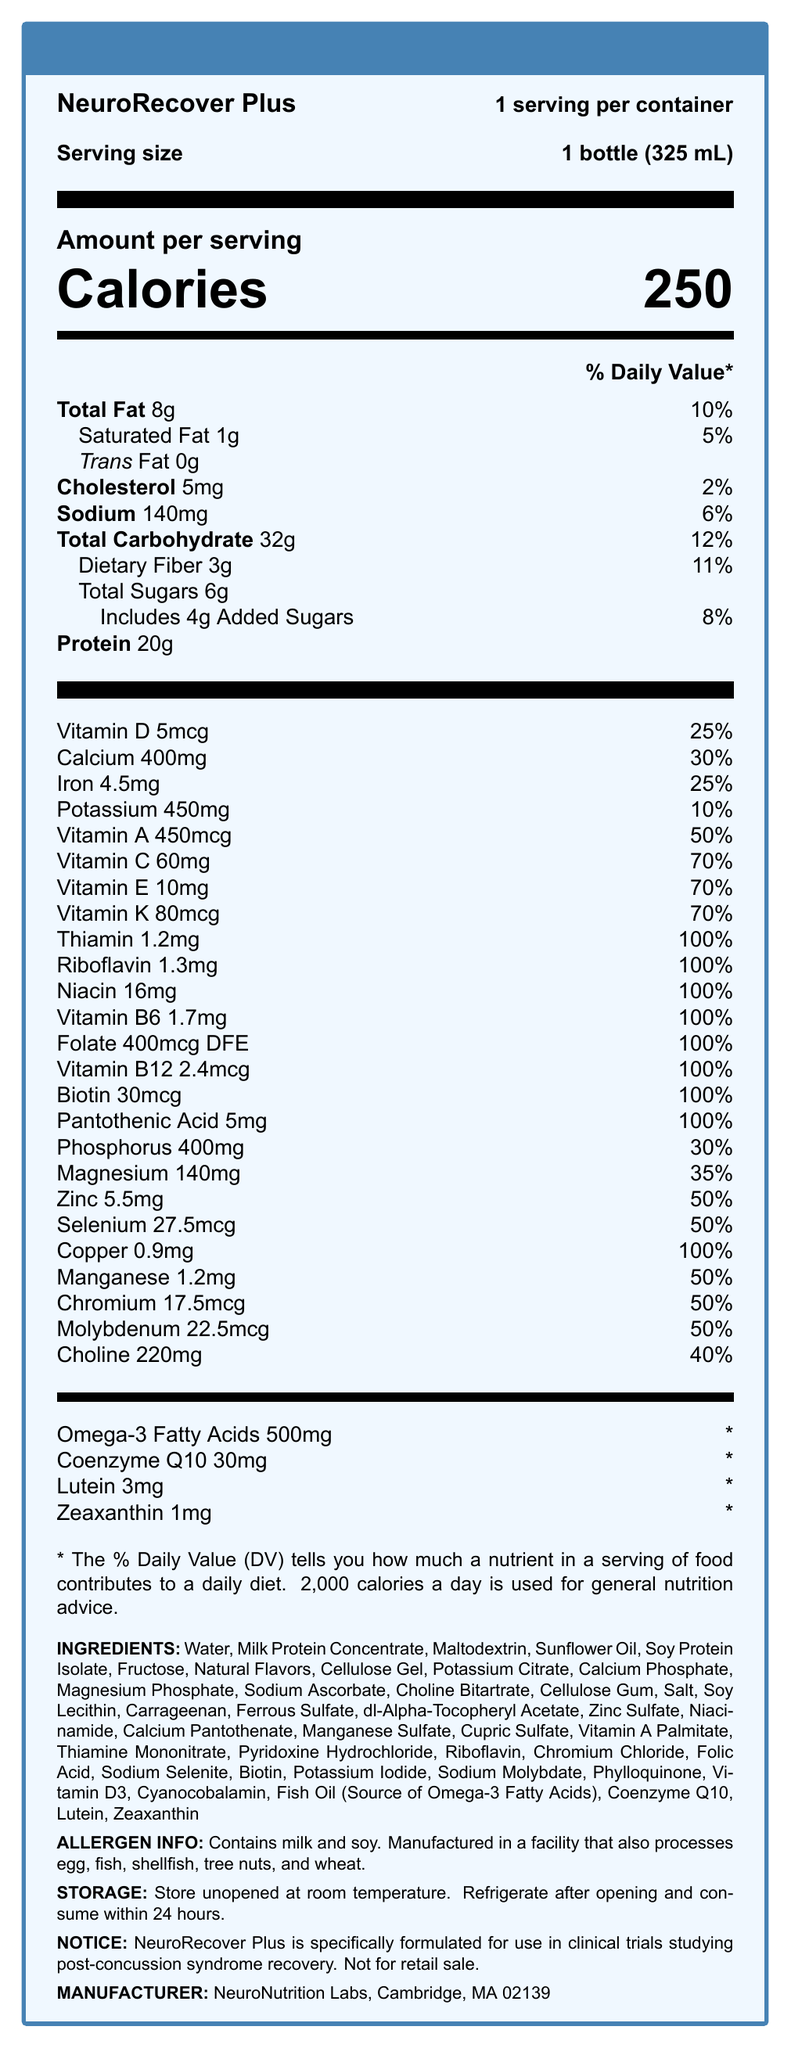what is the serving size of NeuroRecover Plus? The serving size is clearly stated as "1 bottle (325 mL)" in the document.
Answer: 1 bottle (325 mL) how many calories are in one serving? The document lists the calories per serving as 250.
Answer: 250 what is the percentage of daily value for calcium? The document specifies that the daily value for calcium is 30%.
Answer: 30% how much protein does one serving contain? The amount of protein per serving is listed as 20g in the document.
Answer: 20g what are the first three ingredients listed? The first three ingredients listed in the ingredients section are Water, Milk Protein Concentrate, and Maltodextrin.
Answer: Water, Milk Protein Concentrate, Maltodextrin what vitamins are present in 100% daily value in one serving? A. Vitamin C, Folate B. Riboflavin, Vitamin B6 C. Vitamin D, Calcium D. Vitamin E, Sodium The document states that Riboflavin and Vitamin B6 both have 100% daily value per serving.
Answer: B. Riboflavin, Vitamin B6 what is the sugar content in the shake? The document lists 6g of total sugars and includes 4g of added sugars.
Answer: 6g of total sugars, including 4g of added sugars which of the following nutrients does not have an established daily value? I. Omega-3 Fatty Acids II. Zinc III. Coenzyme Q10 IV. Dietary Fiber The document notes that the daily values for Omega-3 Fatty Acids and Coenzyme Q10 are not established (*).
Answer: I. Omega-3 Fatty Acids, III. Coenzyme Q10 is the product suitable for someone with a milk allergy? The allergen information section states that the product contains milk and soy.
Answer: No does the nutrition facts label include fiber content? The document lists Dietary Fiber as part of the total carbohydrate content, specifically 3g per serving.
Answer: Yes summarize the main information provided by the document. This summary captures the main elements of the document, including what the product is, its intended use, key nutritional details, ingredients, allergen warnings, storage instructions, and the specific mention of its use in clinical trials.
Answer: The document is a nutrition facts label for NeuroRecover Plus, a fortified meal replacement shake designed for clinical trials with post-concussion syndrome patients. It includes detailed nutritional information, ingredient list, allergen warnings, storage instructions, and clinical trial usage notice. Key nutrients and their daily values, serving size, calories, and other essential details are provided. how much phosphorus is present in one serving? The document specifies that each serving contains 400mg of phosphorus.
Answer: 400mg are there any sources of omega-3 fatty acids listed among the ingredients? The document lists Fish Oil (Source of Omega-3 Fatty Acids) as one of the ingredients.
Answer: Yes how long can NeuroRecover Plus be stored after opening? The storage instructions state to refrigerate after opening and consume within 24 hours.
Answer: 24 hours where was NeuroRecover Plus manufactured? The manufacturer information at the bottom of the document states it was made by NeuroNutrition Labs in Cambridge, MA 02139.
Answer: Cambridge, MA 02139 how much Coenzyme Q10 is included in one serving? The document specifies that there are 30mg of Coenzyme Q10 per serving.
Answer: 30mg what is the total fat content in the meal replacement shake? The document lists total fat content as 8g per serving.
Answer: 8g which ingredients are included in the shake for vitamin supplementation? The document lists these ingredients, which are commonly used for vitamin supplementation.
Answer: Sodium Ascorbate, dl-Alpha-Tocopheryl Acetate, Niacinamide, Calcium Pantothenate, Vitamins A, D3, Riboflavin, Pyridoxine Hydrochloride, Thiamine Mononitrate, Folic Acid, Cyanocobalamin are there any ingredients that might make this product unsuitable for people with a soy allergy? The allergen information section specifically says the product contains soy.
Answer: Yes 